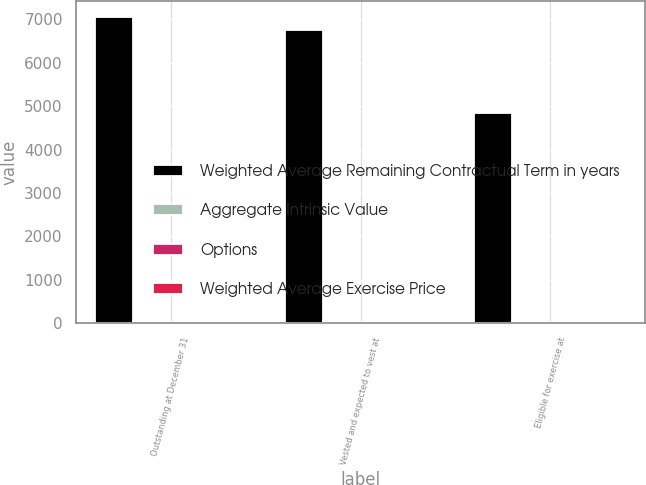Convert chart. <chart><loc_0><loc_0><loc_500><loc_500><stacked_bar_chart><ecel><fcel>Outstanding at December 31<fcel>Vested and expected to vest at<fcel>Eligible for exercise at<nl><fcel>Weighted Average Remaining Contractual Term in years<fcel>7062<fcel>6759<fcel>4849<nl><fcel>Aggregate Intrinsic Value<fcel>14.83<fcel>14.89<fcel>15.61<nl><fcel>Options<fcel>5<fcel>4.9<fcel>3.4<nl><fcel>Weighted Average Exercise Price<fcel>8<fcel>8<fcel>6<nl></chart> 